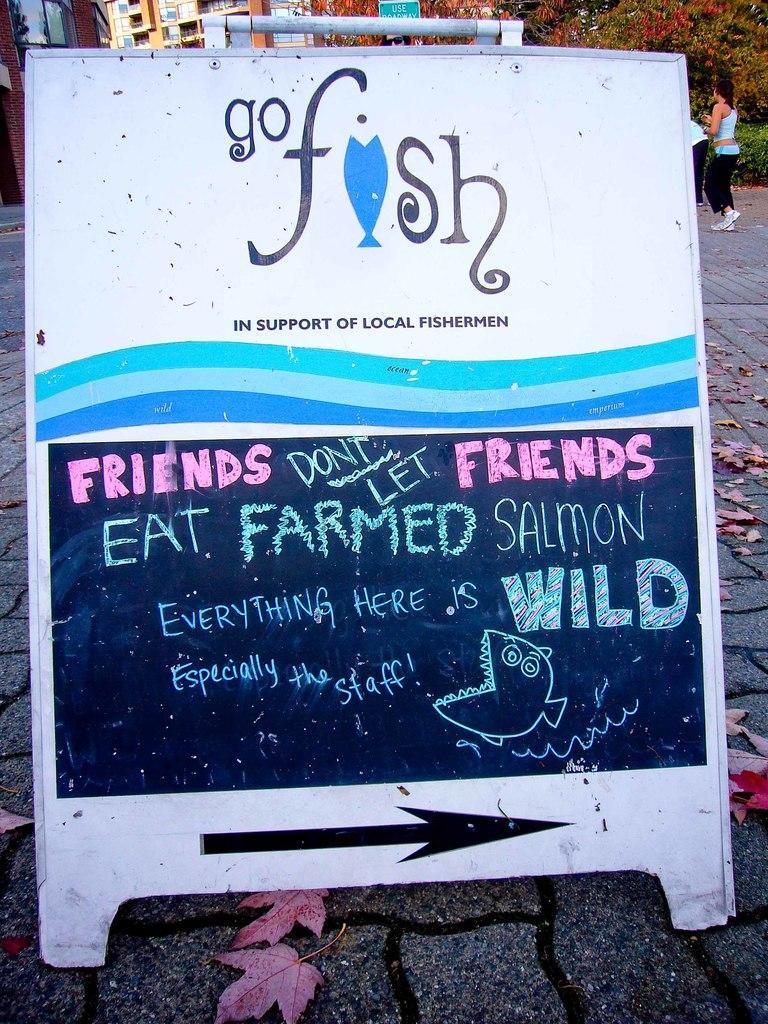How would you summarize this image in a sentence or two? In this image, we can see a board with some text and images. We can see the ground with some dried leaves. There are a few buildings. We can also see a person and some plants. We can also see some trees. 